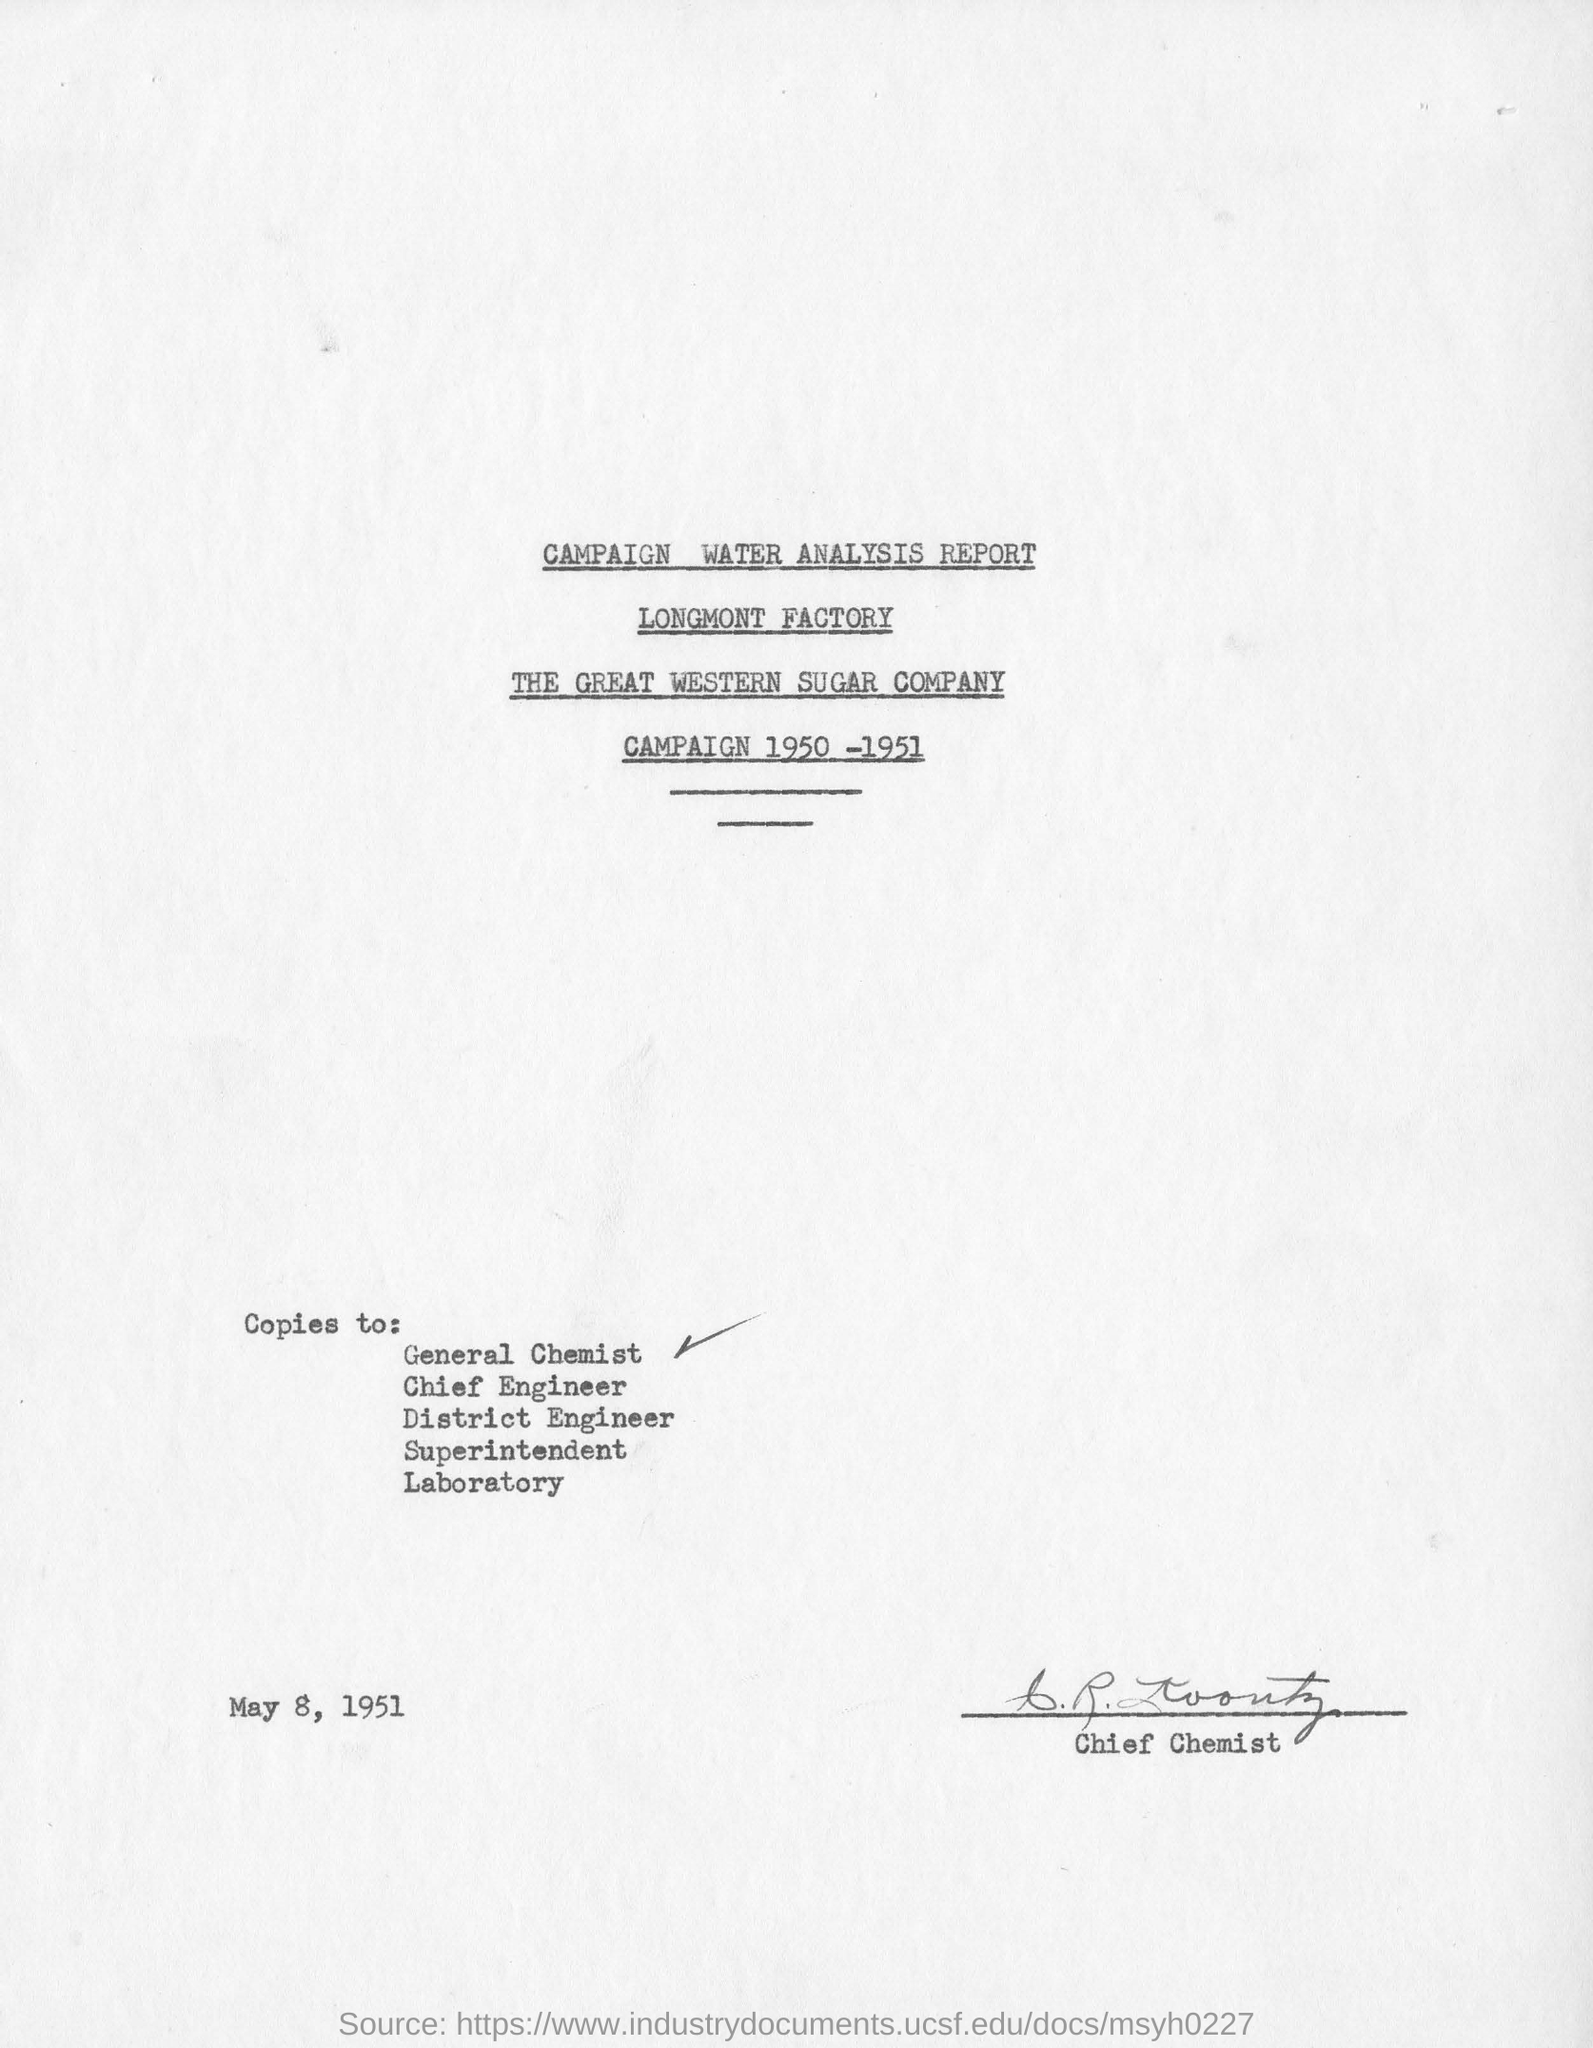Which is the date mentioned in the report?
Offer a terse response. MAY 8, 1951. 